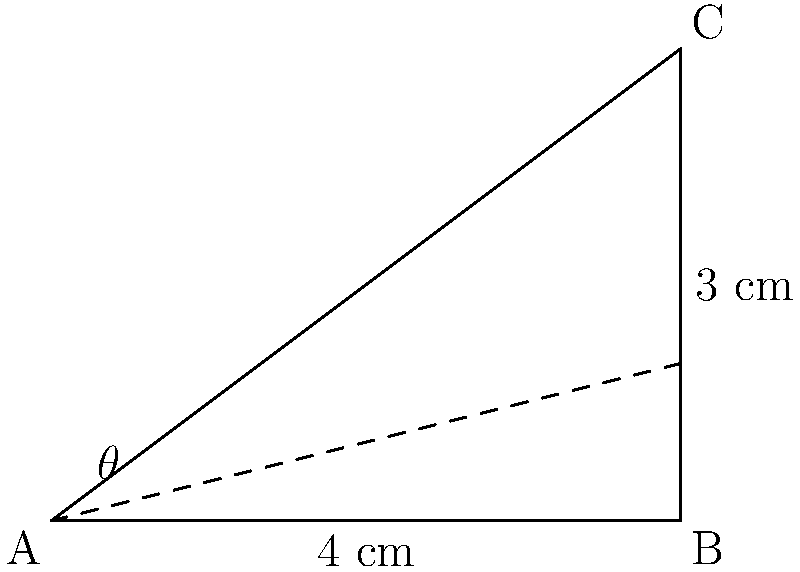In designing a pistol grip, you need to determine the optimal angle for user comfort and control. The grip is represented by the triangle ABC in the diagram. If the base of the grip (AB) is 4 cm long and the height (BC) is 3 cm, what is the angle $\theta$ between the grip and the horizontal plane to the nearest degree? To find the angle $\theta$, we can use the arctangent function, as we have the opposite and adjacent sides of the right triangle.

1. Identify the sides:
   - Opposite side (BC) = 3 cm
   - Adjacent side (AB) = 4 cm

2. Use the tangent function:
   $\tan(\theta) = \frac{\text{opposite}}{\text{adjacent}} = \frac{3}{4}$

3. To find $\theta$, we need to use the inverse tangent (arctangent) function:
   $\theta = \arctan(\frac{3}{4})$

4. Calculate using a calculator or computer:
   $\theta \approx 36.87°$

5. Round to the nearest degree:
   $\theta \approx 37°$

This angle provides an optimal balance between comfort and control for the pistol grip design.
Answer: $37°$ 